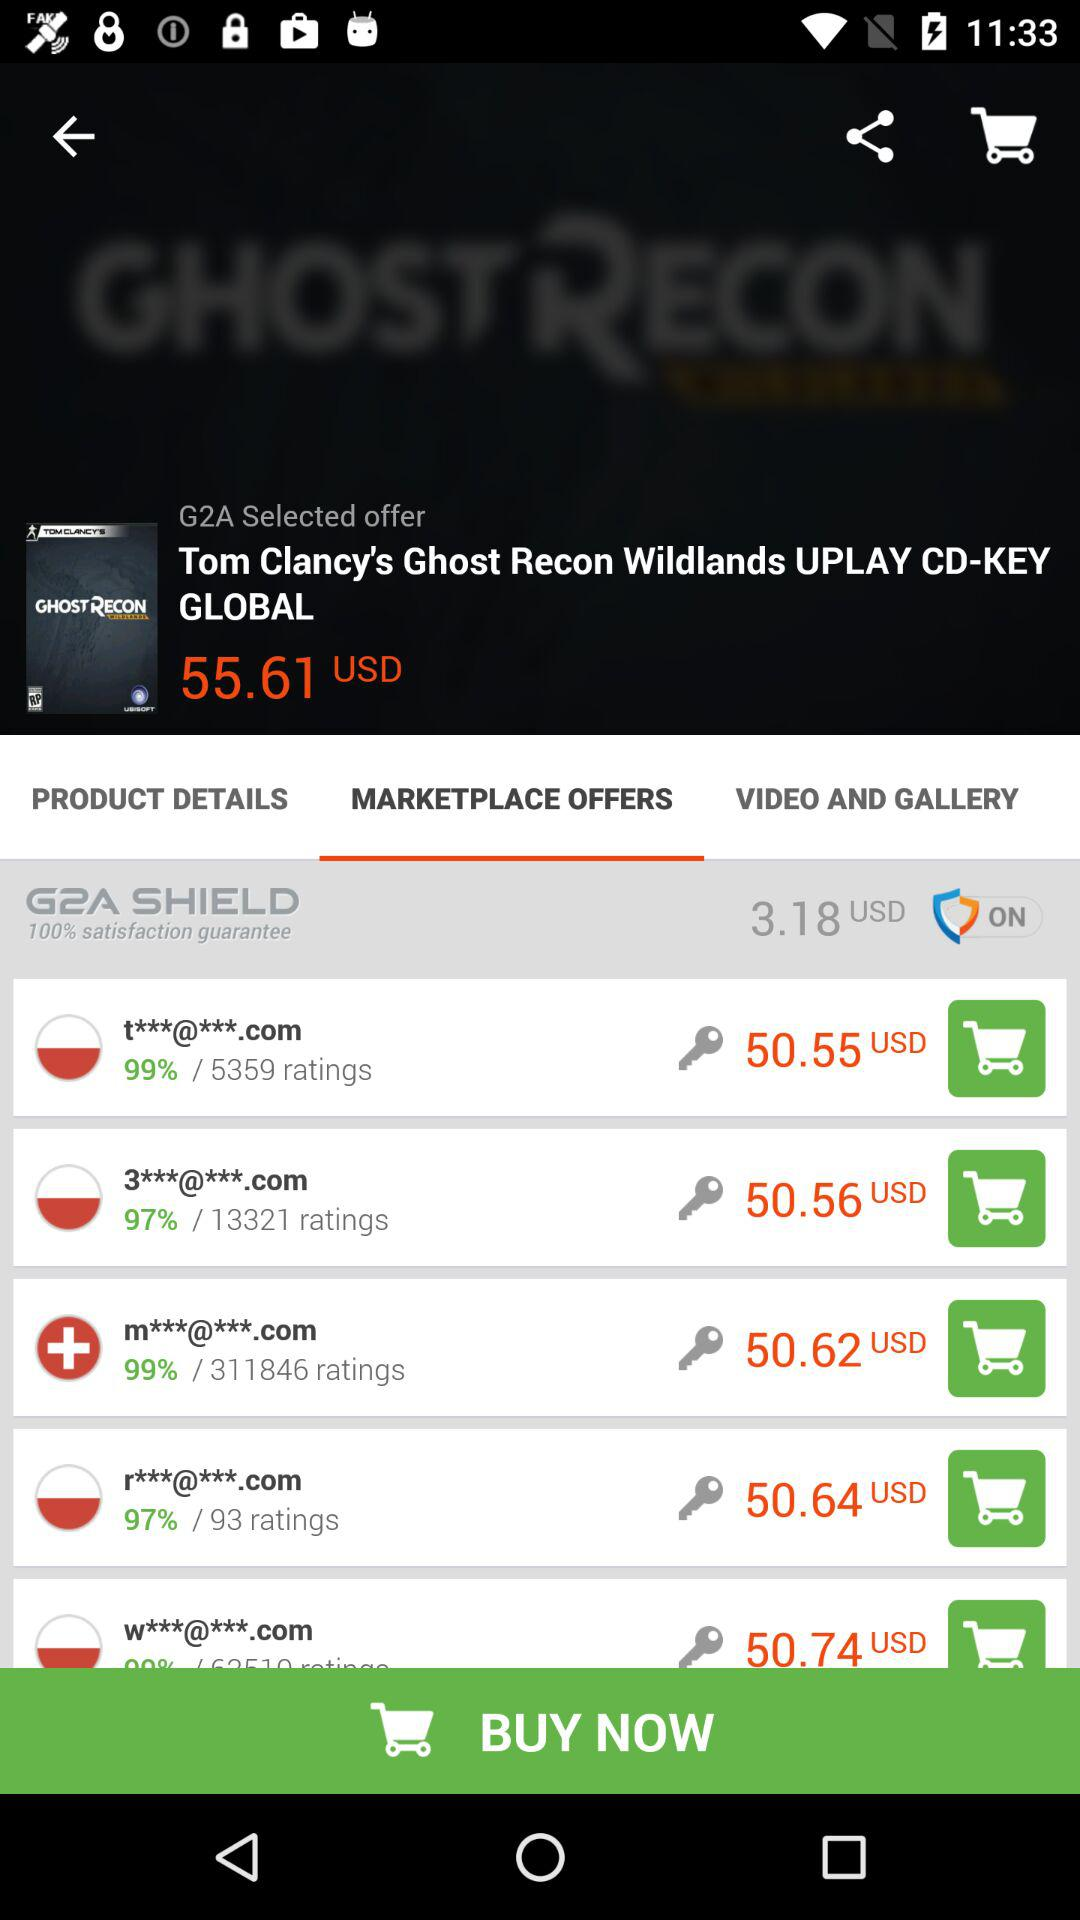How much does the G2A shield cost? The G2A shield cost is "3.18 USD". 